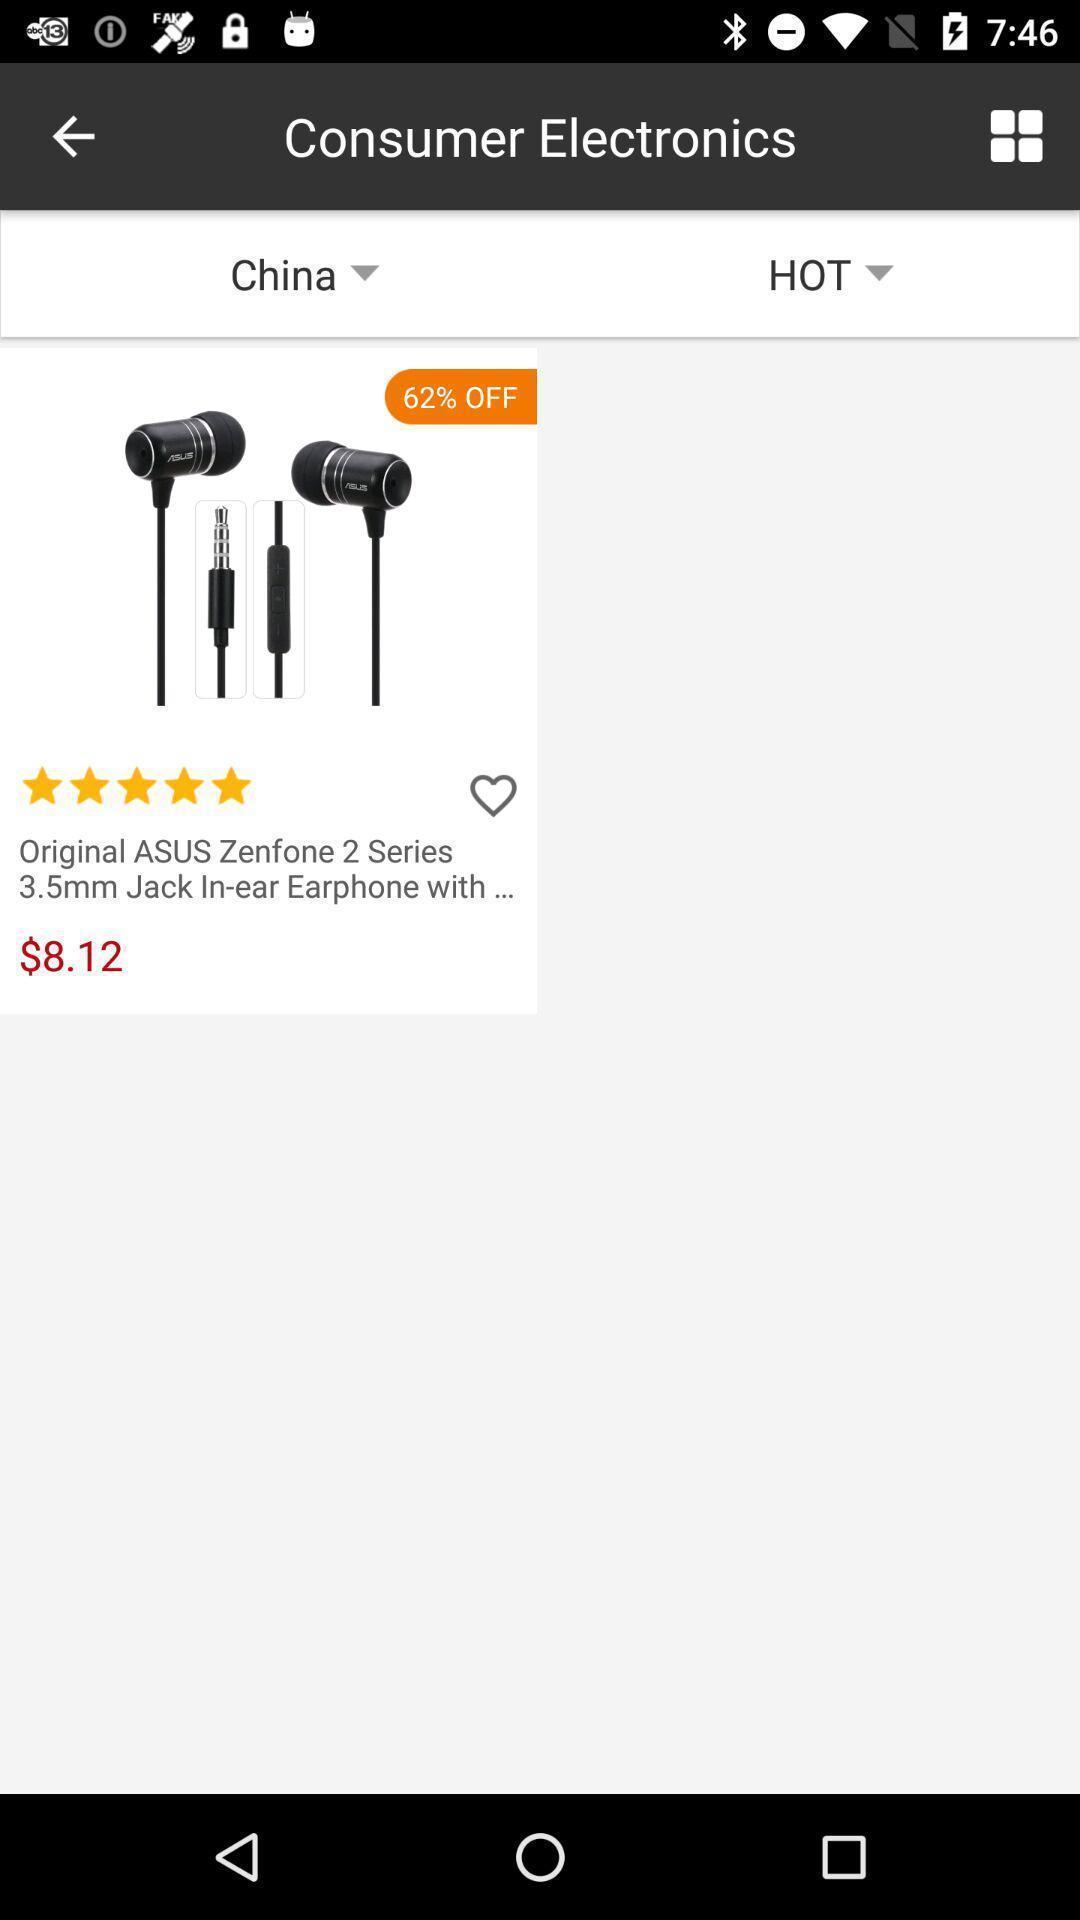What is the overall content of this screenshot? Screen shows product details in shopping app. 